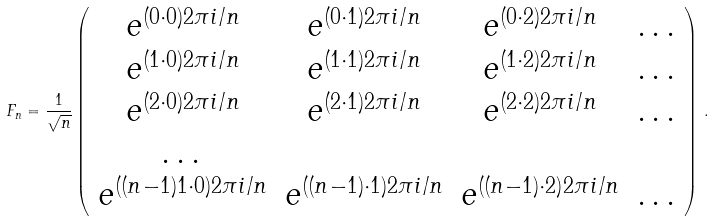Convert formula to latex. <formula><loc_0><loc_0><loc_500><loc_500>F _ { n } = \frac { 1 } { \sqrt { n } } \left ( \begin{array} { c c c c c c } e ^ { ( 0 \cdot 0 ) 2 \pi i / n } & e ^ { ( 0 \cdot 1 ) 2 \pi i / n } & e ^ { ( 0 \cdot 2 ) 2 \pi i / n } & \dots \\ e ^ { ( 1 \cdot 0 ) 2 \pi i / n } & e ^ { ( 1 \cdot 1 ) 2 \pi i / n } & e ^ { ( 1 \cdot 2 ) 2 \pi i / n } & \dots \\ e ^ { ( 2 \cdot 0 ) 2 \pi i / n } & e ^ { ( 2 \cdot 1 ) 2 \pi i / n } & e ^ { ( 2 \cdot 2 ) 2 \pi i / n } & \dots \\ \dots & & & \\ e ^ { ( ( n - 1 ) 1 \cdot 0 ) 2 \pi i / n } & e ^ { ( ( n - 1 ) \cdot 1 ) 2 \pi i / n } & e ^ { ( ( n - 1 ) \cdot 2 ) 2 \pi i / n } & \dots \end{array} \right ) \, .</formula> 